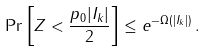Convert formula to latex. <formula><loc_0><loc_0><loc_500><loc_500>\Pr \left [ Z < \frac { p _ { 0 } | I _ { k } | } { 2 } \right ] \leq e ^ { - \Omega ( | I _ { k } | ) } \, .</formula> 